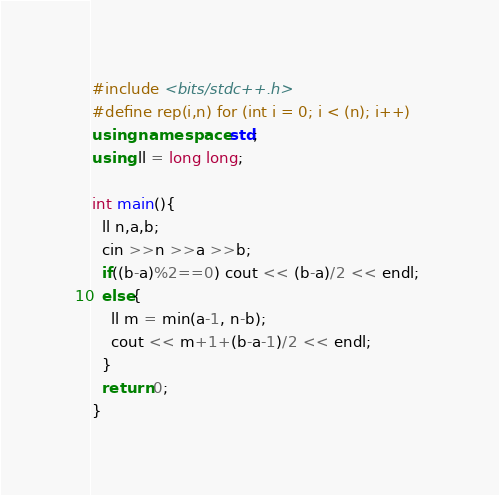Convert code to text. <code><loc_0><loc_0><loc_500><loc_500><_C++_>#include <bits/stdc++.h>
#define rep(i,n) for (int i = 0; i < (n); i++)
using namespace std;
using ll = long long;

int main(){
  ll n,a,b; 
  cin >>n >>a >>b;
  if((b-a)%2==0) cout << (b-a)/2 << endl; 
  else{
    ll m = min(a-1, n-b);
    cout << m+1+(b-a-1)/2 << endl;
  }
  return 0; 
}</code> 